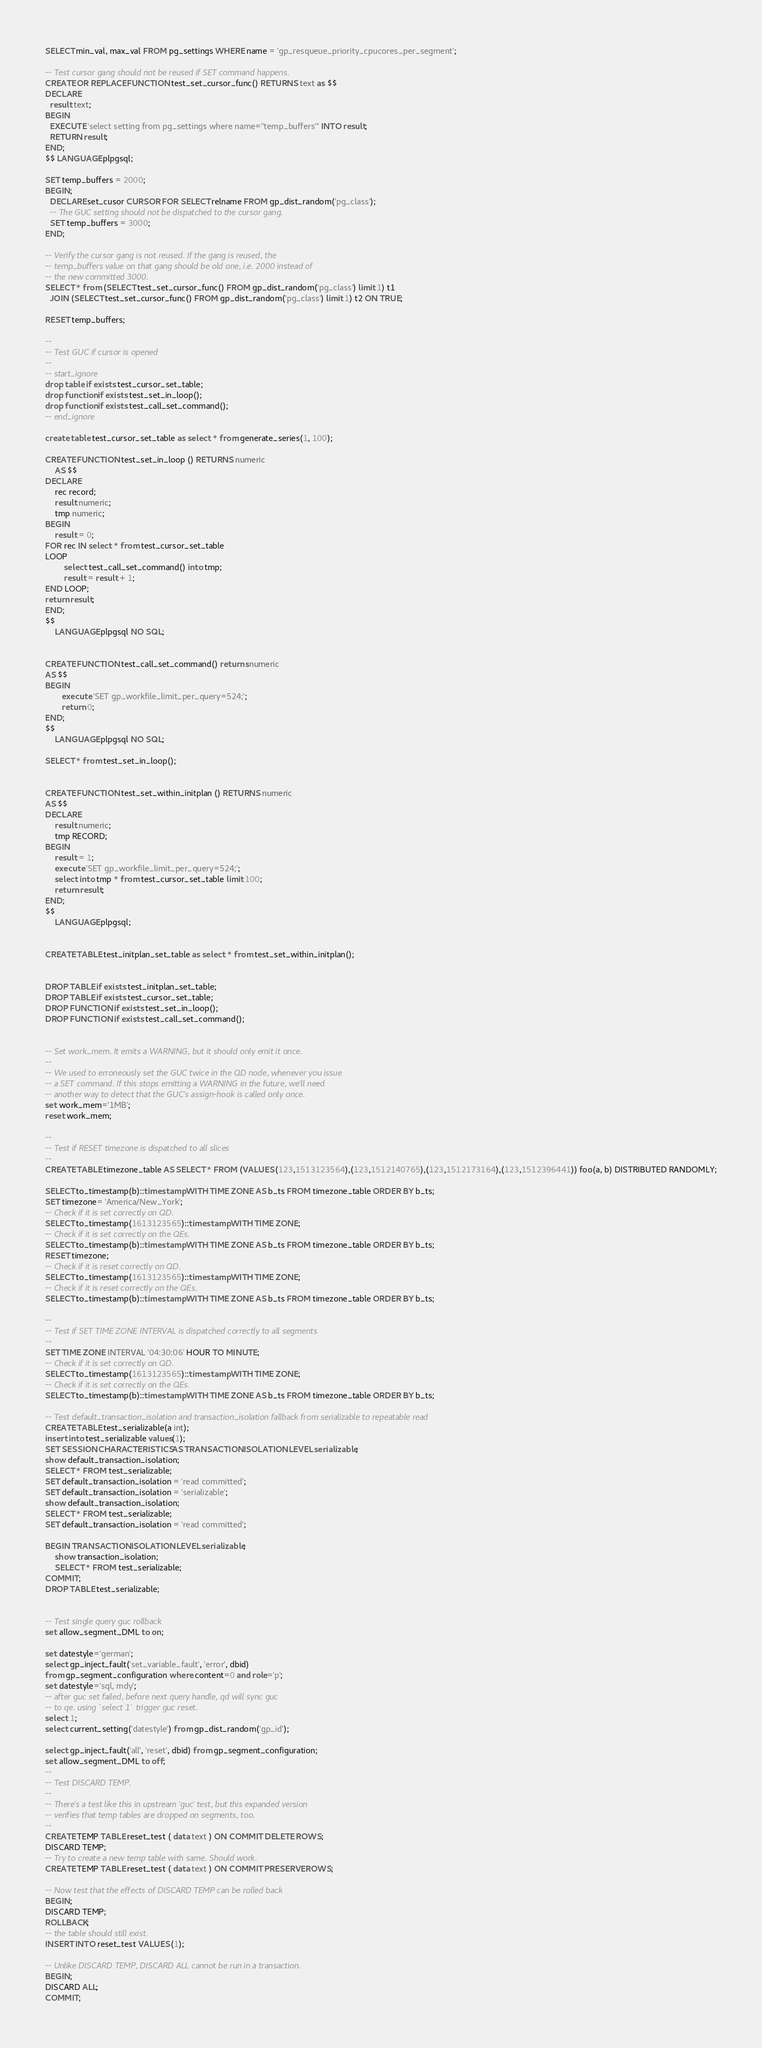Convert code to text. <code><loc_0><loc_0><loc_500><loc_500><_SQL_>SELECT min_val, max_val FROM pg_settings WHERE name = 'gp_resqueue_priority_cpucores_per_segment';

-- Test cursor gang should not be reused if SET command happens.
CREATE OR REPLACE FUNCTION test_set_cursor_func() RETURNS text as $$
DECLARE
  result text;
BEGIN
  EXECUTE 'select setting from pg_settings where name=''temp_buffers''' INTO result;
  RETURN result;
END;
$$ LANGUAGE plpgsql;

SET temp_buffers = 2000;
BEGIN;
  DECLARE set_cusor CURSOR FOR SELECT relname FROM gp_dist_random('pg_class');
  -- The GUC setting should not be dispatched to the cursor gang.
  SET temp_buffers = 3000;
END;

-- Verify the cursor gang is not reused. If the gang is reused, the
-- temp_buffers value on that gang should be old one, i.e. 2000 instead of
-- the new committed 3000.
SELECT * from (SELECT test_set_cursor_func() FROM gp_dist_random('pg_class') limit 1) t1
  JOIN (SELECT test_set_cursor_func() FROM gp_dist_random('pg_class') limit 1) t2 ON TRUE;

RESET temp_buffers;

--
-- Test GUC if cursor is opened
--
-- start_ignore
drop table if exists test_cursor_set_table;
drop function if exists test_set_in_loop();
drop function if exists test_call_set_command();
-- end_ignore

create table test_cursor_set_table as select * from generate_series(1, 100);

CREATE FUNCTION test_set_in_loop () RETURNS numeric
    AS $$
DECLARE
    rec record;
    result numeric;
    tmp numeric;
BEGIN
	result = 0;
FOR rec IN select * from test_cursor_set_table
LOOP
        select test_call_set_command() into tmp;
        result = result + 1;
END LOOP;
return result;
END;
$$
    LANGUAGE plpgsql NO SQL;


CREATE FUNCTION test_call_set_command() returns numeric
AS $$
BEGIN
       execute 'SET gp_workfile_limit_per_query=524;';
       return 0;
END;
$$
    LANGUAGE plpgsql NO SQL;

SELECT * from test_set_in_loop();


CREATE FUNCTION test_set_within_initplan () RETURNS numeric
AS $$
DECLARE
	result numeric;
	tmp RECORD;
BEGIN
	result = 1;
	execute 'SET gp_workfile_limit_per_query=524;';
	select into tmp * from test_cursor_set_table limit 100;
	return result;
END;
$$
	LANGUAGE plpgsql;


CREATE TABLE test_initplan_set_table as select * from test_set_within_initplan();


DROP TABLE if exists test_initplan_set_table;
DROP TABLE if exists test_cursor_set_table;
DROP FUNCTION if exists test_set_in_loop();
DROP FUNCTION if exists test_call_set_command();


-- Set work_mem. It emits a WARNING, but it should only emit it once.
--
-- We used to erroneously set the GUC twice in the QD node, whenever you issue
-- a SET command. If this stops emitting a WARNING in the future, we'll need
-- another way to detect that the GUC's assign-hook is called only once.
set work_mem='1MB';
reset work_mem;

--
-- Test if RESET timezone is dispatched to all slices
--
CREATE TABLE timezone_table AS SELECT * FROM (VALUES (123,1513123564),(123,1512140765),(123,1512173164),(123,1512396441)) foo(a, b) DISTRIBUTED RANDOMLY;

SELECT to_timestamp(b)::timestamp WITH TIME ZONE AS b_ts FROM timezone_table ORDER BY b_ts;
SET timezone= 'America/New_York';
-- Check if it is set correctly on QD.
SELECT to_timestamp(1613123565)::timestamp WITH TIME ZONE;
-- Check if it is set correctly on the QEs.
SELECT to_timestamp(b)::timestamp WITH TIME ZONE AS b_ts FROM timezone_table ORDER BY b_ts;
RESET timezone;
-- Check if it is reset correctly on QD.
SELECT to_timestamp(1613123565)::timestamp WITH TIME ZONE;
-- Check if it is reset correctly on the QEs.
SELECT to_timestamp(b)::timestamp WITH TIME ZONE AS b_ts FROM timezone_table ORDER BY b_ts;

--
-- Test if SET TIME ZONE INTERVAL is dispatched correctly to all segments
--
SET TIME ZONE INTERVAL '04:30:06' HOUR TO MINUTE;
-- Check if it is set correctly on QD.
SELECT to_timestamp(1613123565)::timestamp WITH TIME ZONE;
-- Check if it is set correctly on the QEs.
SELECT to_timestamp(b)::timestamp WITH TIME ZONE AS b_ts FROM timezone_table ORDER BY b_ts;

-- Test default_transaction_isolation and transaction_isolation fallback from serializable to repeatable read
CREATE TABLE test_serializable(a int);
insert into test_serializable values(1);
SET SESSION CHARACTERISTICS AS TRANSACTION ISOLATION LEVEL serializable;
show default_transaction_isolation;
SELECT * FROM test_serializable;
SET default_transaction_isolation = 'read committed';
SET default_transaction_isolation = 'serializable';
show default_transaction_isolation;
SELECT * FROM test_serializable;
SET default_transaction_isolation = 'read committed';

BEGIN TRANSACTION ISOLATION LEVEL serializable;
	show transaction_isolation;
	SELECT * FROM test_serializable;
COMMIT;
DROP TABLE test_serializable;


-- Test single query guc rollback
set allow_segment_DML to on;

set datestyle='german';
select gp_inject_fault('set_variable_fault', 'error', dbid)
from gp_segment_configuration where content=0 and role='p';
set datestyle='sql, mdy';
-- after guc set failed, before next query handle, qd will sync guc
-- to qe. using `select 1` trigger guc reset.
select 1;
select current_setting('datestyle') from gp_dist_random('gp_id');

select gp_inject_fault('all', 'reset', dbid) from gp_segment_configuration;
set allow_segment_DML to off;
--
-- Test DISCARD TEMP.
--
-- There's a test like this in upstream 'guc' test, but this expanded version
-- verifies that temp tables are dropped on segments, too.
--
CREATE TEMP TABLE reset_test ( data text ) ON COMMIT DELETE ROWS;
DISCARD TEMP;
-- Try to create a new temp table with same. Should work.
CREATE TEMP TABLE reset_test ( data text ) ON COMMIT PRESERVE ROWS;

-- Now test that the effects of DISCARD TEMP can be rolled back
BEGIN;
DISCARD TEMP;
ROLLBACK;
-- the table should still exist.
INSERT INTO reset_test VALUES (1);

-- Unlike DISCARD TEMP, DISCARD ALL cannot be run in a transaction.
BEGIN;
DISCARD ALL;
COMMIT;</code> 